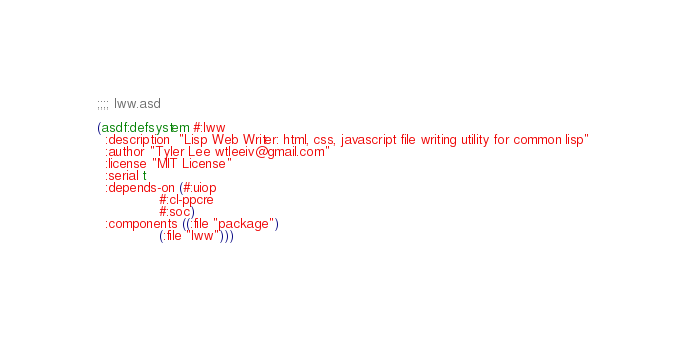Convert code to text. <code><loc_0><loc_0><loc_500><loc_500><_Lisp_>;;;; lww.asd

(asdf:defsystem #:lww
  :description  "Lisp Web Writer: html, css, javascript file writing utility for common lisp"
  :author "Tyler Lee wtleeiv@gmail.com"
  :license "MIT License"
  :serial t
  :depends-on (#:uiop
               #:cl-ppcre
               #:soc)
  :components ((:file "package")
               (:file "lww")))

</code> 